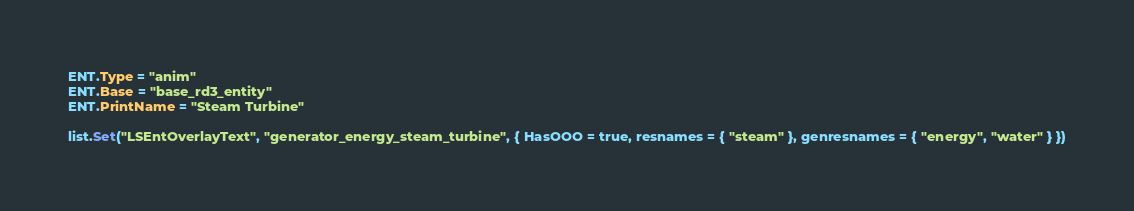<code> <loc_0><loc_0><loc_500><loc_500><_Lua_>ENT.Type = "anim"
ENT.Base = "base_rd3_entity"
ENT.PrintName = "Steam Turbine"

list.Set("LSEntOverlayText", "generator_energy_steam_turbine", { HasOOO = true, resnames = { "steam" }, genresnames = { "energy", "water" } })
</code> 